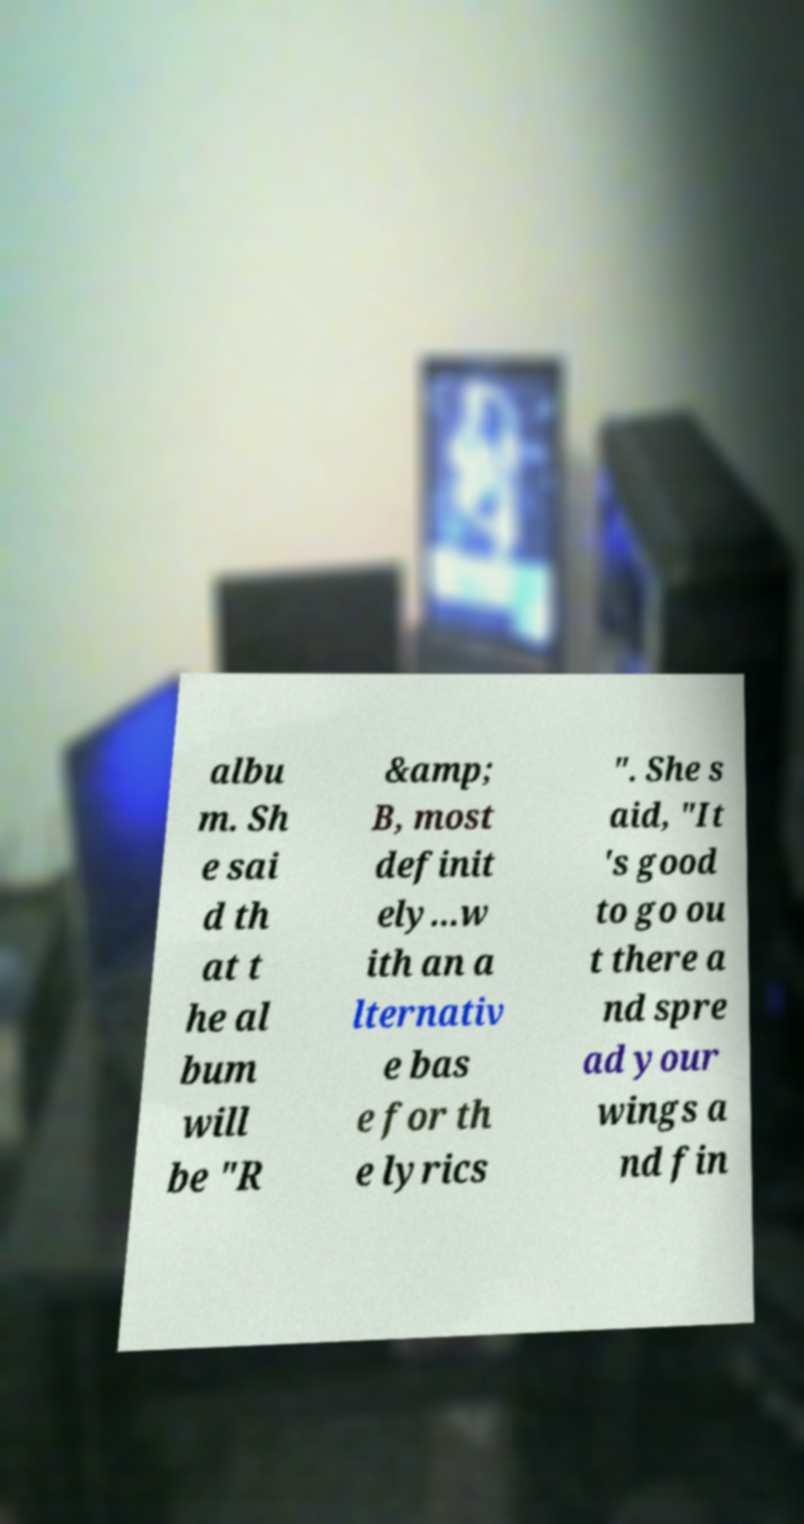I need the written content from this picture converted into text. Can you do that? albu m. Sh e sai d th at t he al bum will be "R &amp; B, most definit ely...w ith an a lternativ e bas e for th e lyrics ". She s aid, "It 's good to go ou t there a nd spre ad your wings a nd fin 